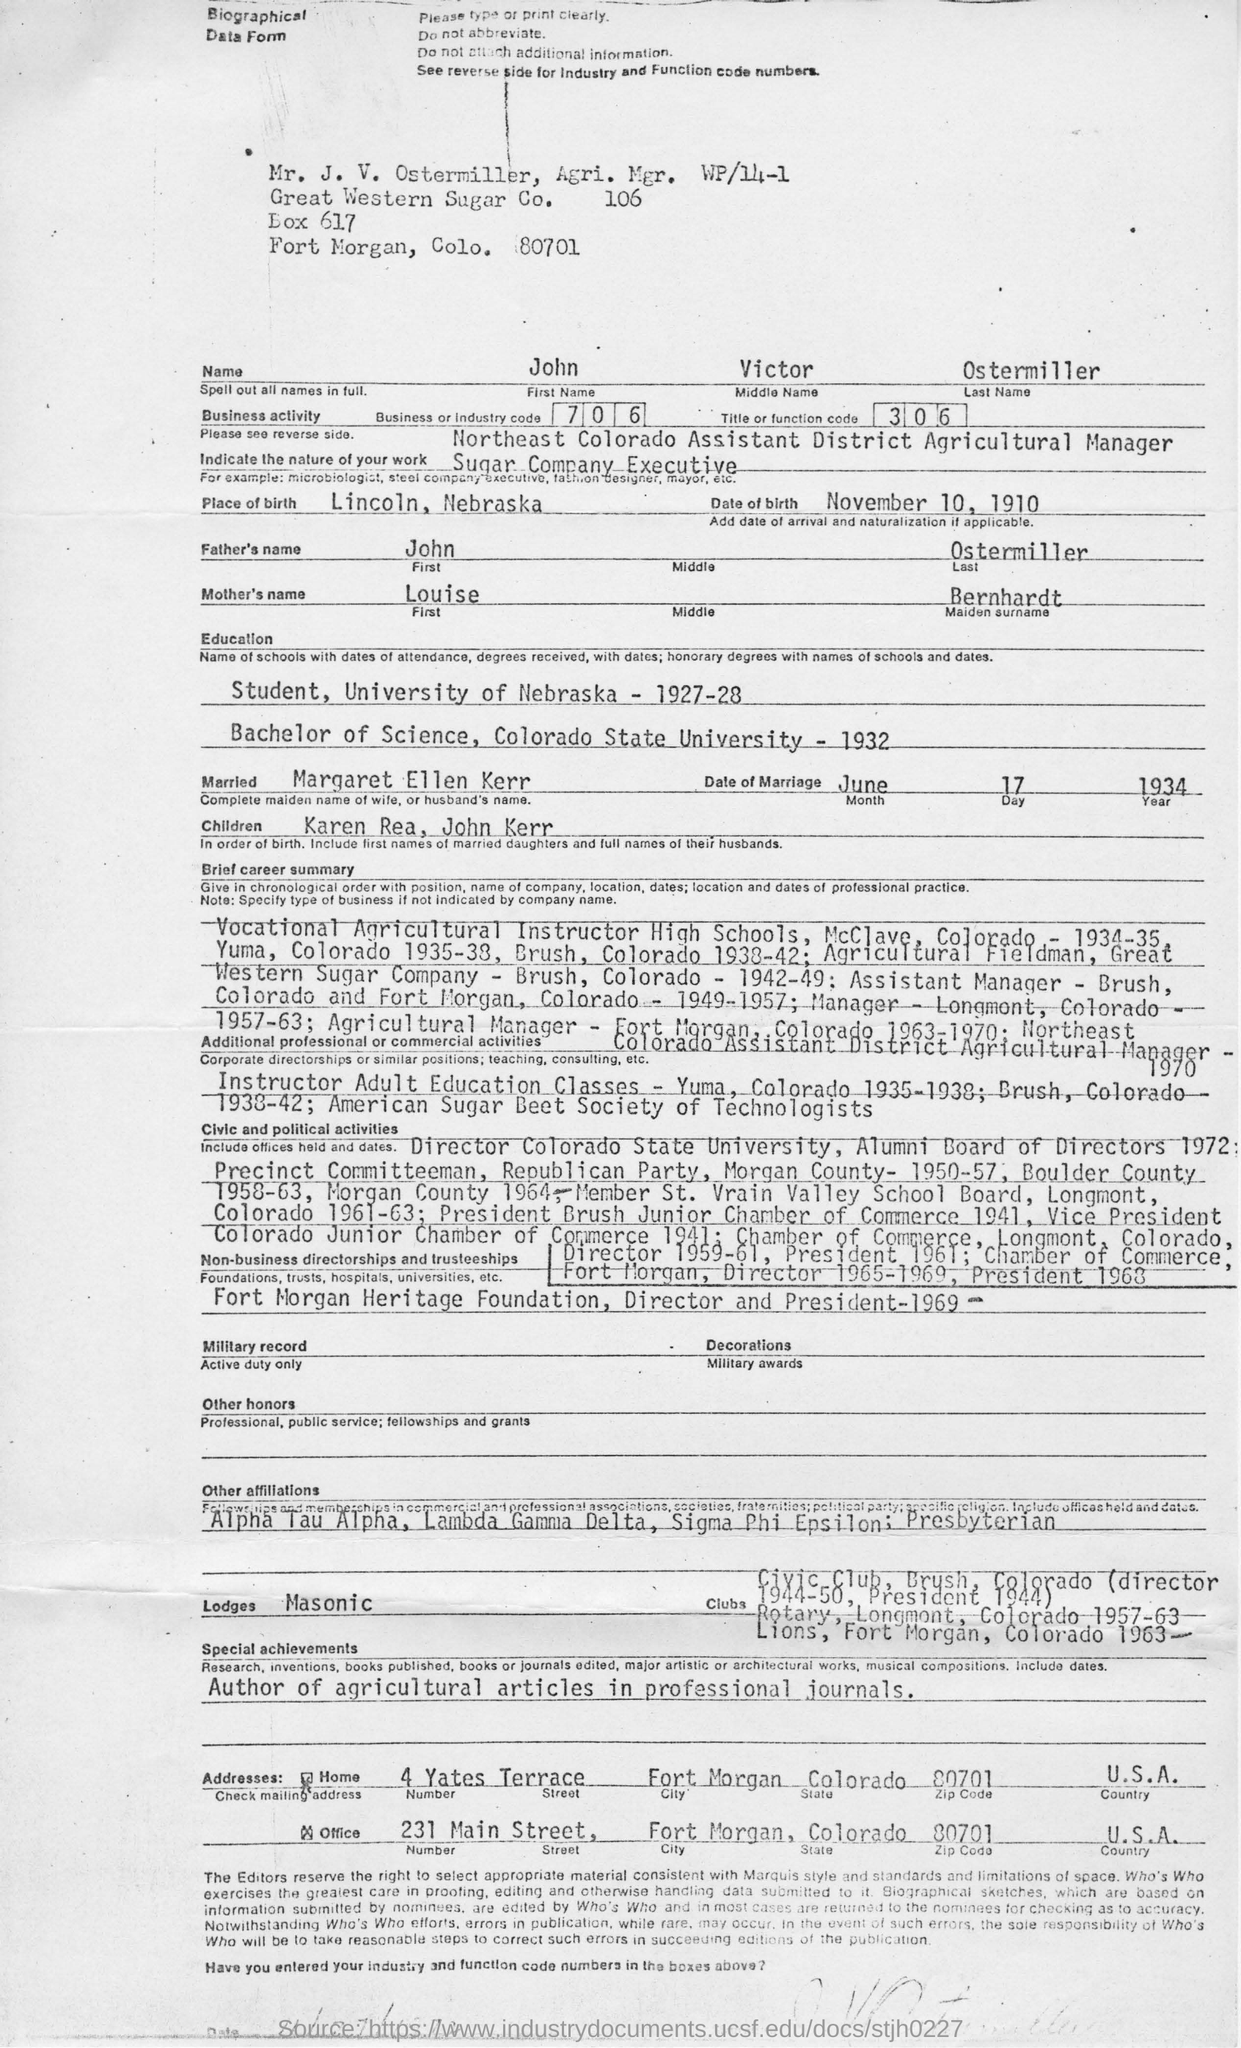Point out several critical features in this image. John authored articles on agriculture that were published in professional journals. John is married to Margaret Ellen Kerr. John Victor Ostermiller is a sugar company executive with a nature of work that involves leadership and management of the company's operations. John obtained his Bachelor of Science degree from Colorado State University. The person's name is John Victor Ostermiller. 